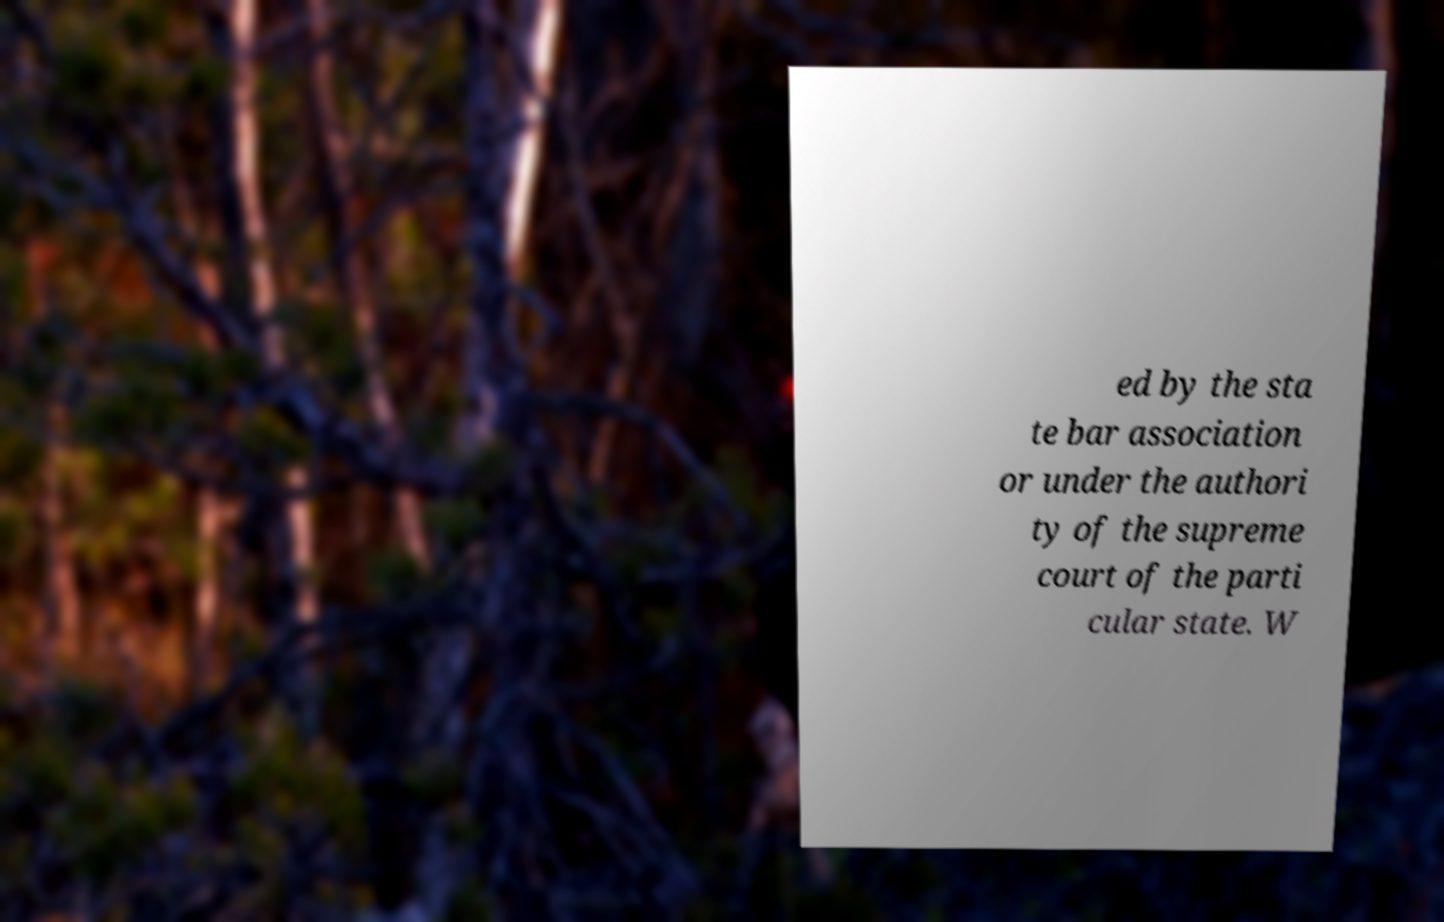Could you assist in decoding the text presented in this image and type it out clearly? ed by the sta te bar association or under the authori ty of the supreme court of the parti cular state. W 